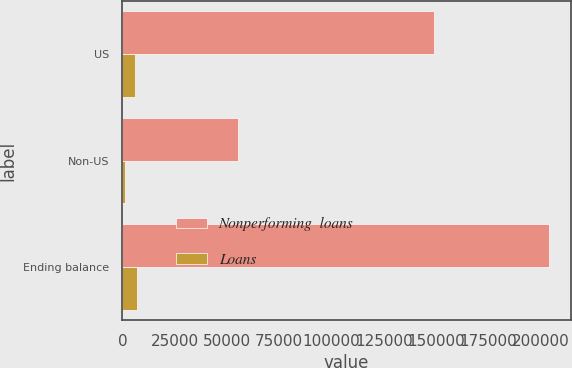<chart> <loc_0><loc_0><loc_500><loc_500><stacked_bar_chart><ecel><fcel>US<fcel>Non-US<fcel>Ending balance<nl><fcel>Nonperforming  loans<fcel>149085<fcel>55090<fcel>204175<nl><fcel>Loans<fcel>5844<fcel>1060<fcel>6904<nl></chart> 